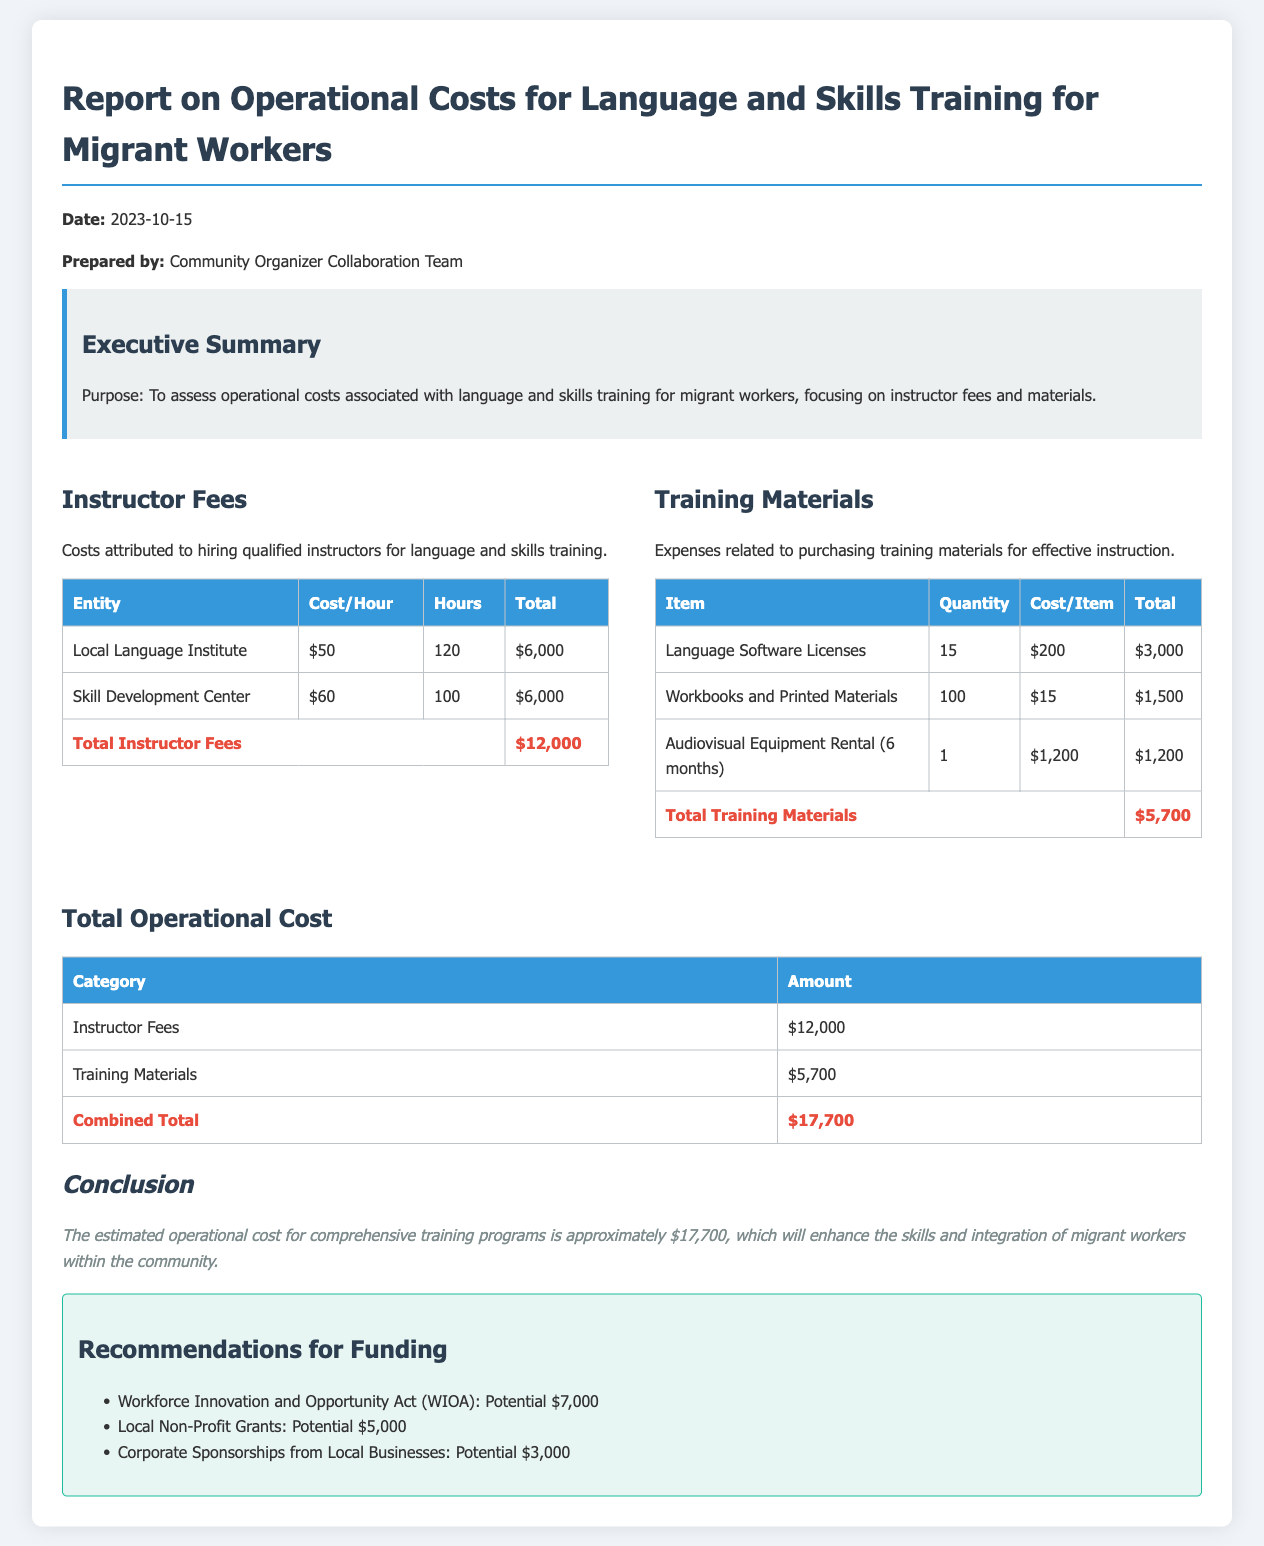what is the date of the report? The date of the report is mentioned in the document header.
Answer: 2023-10-15 who prepared the report? The report is prepared by a specific team that is stated in the document.
Answer: Community Organizer Collaboration Team what is the total instructor fees? Total instructor fees are summarized in the section that breaks down costs, presented in a table.
Answer: $12,000 what is the total amount spent on training materials? The total amount for training materials is provided at the end of the respective table.
Answer: $5,700 what is the combined total operational cost? The combined total operational cost is derived from adding the totals of the two main cost categories.
Answer: $17,700 how many hours were dedicated to training by the Skill Development Center? The hours dedicated to training by the Skill Development Center are specified in the instructor fees table.
Answer: 100 what is the cost per hour for the Local Language Institute? This cost is provided in the instructor fees table.
Answer: $50 how many language software licenses were purchased? The quantity of language software licenses is specified in the training materials table.
Answer: 15 what is one recommendation for funding? The document lists several recommendations for funding in a dedicated section.
Answer: Workforce Innovation and Opportunity Act (WIOA): Potential $7,000 